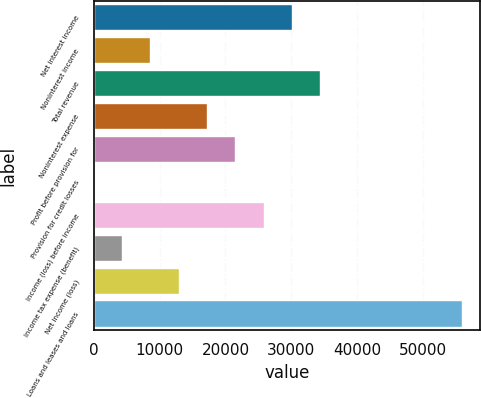Convert chart. <chart><loc_0><loc_0><loc_500><loc_500><bar_chart><fcel>Net interest income<fcel>Noninterest income<fcel>Total revenue<fcel>Noninterest expense<fcel>Profit before provision for<fcel>Provision for credit losses<fcel>Income (loss) before income<fcel>Income tax expense (benefit)<fcel>Net income (loss)<fcel>Loans and leases and loans<nl><fcel>30094.8<fcel>8607.8<fcel>34392.2<fcel>17202.6<fcel>21500<fcel>13<fcel>25797.4<fcel>4310.4<fcel>12905.2<fcel>55879.2<nl></chart> 